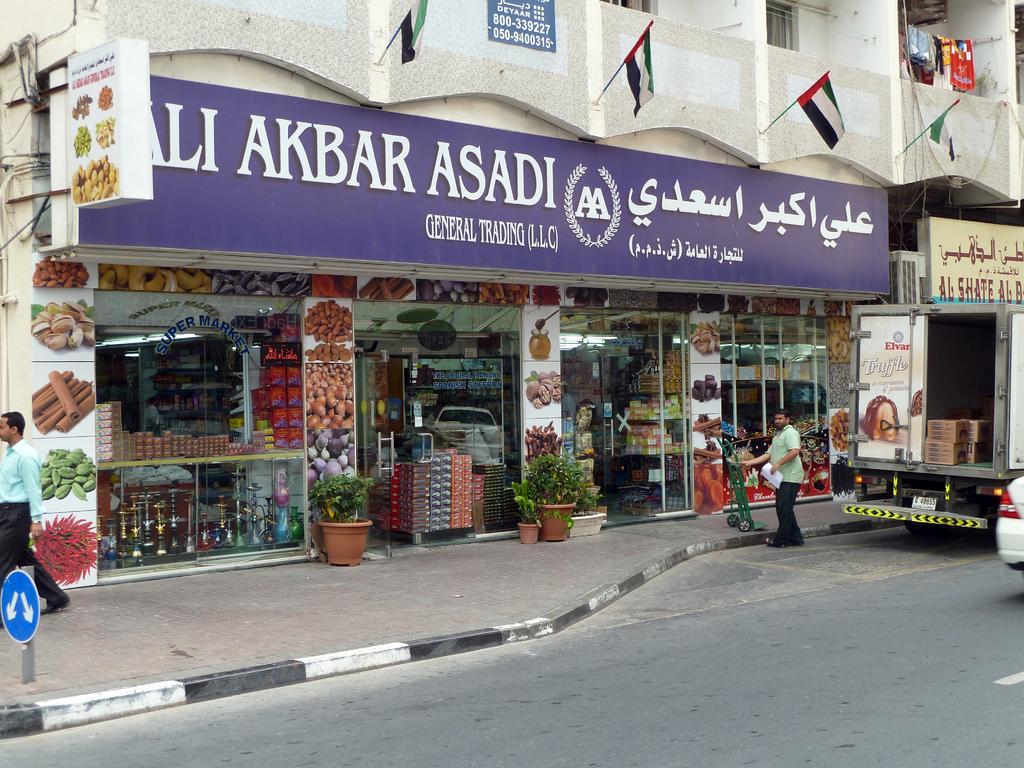Describe this image in one or two sentences. This is an outside view. At the bottom there is a road. On the right side there is a vehicle. Beside the vehicle one man is standing by holding few papers in the hand. On the left side there is a man walking on the footpath. In the background there is a building. At the bottom there is a stall. Here I can see a glass through which we can see the inside view of the stall. There are many objects arranged in the racks. At the top of the image there is a board attached to the wall on which I can see some text and there are few flags. 